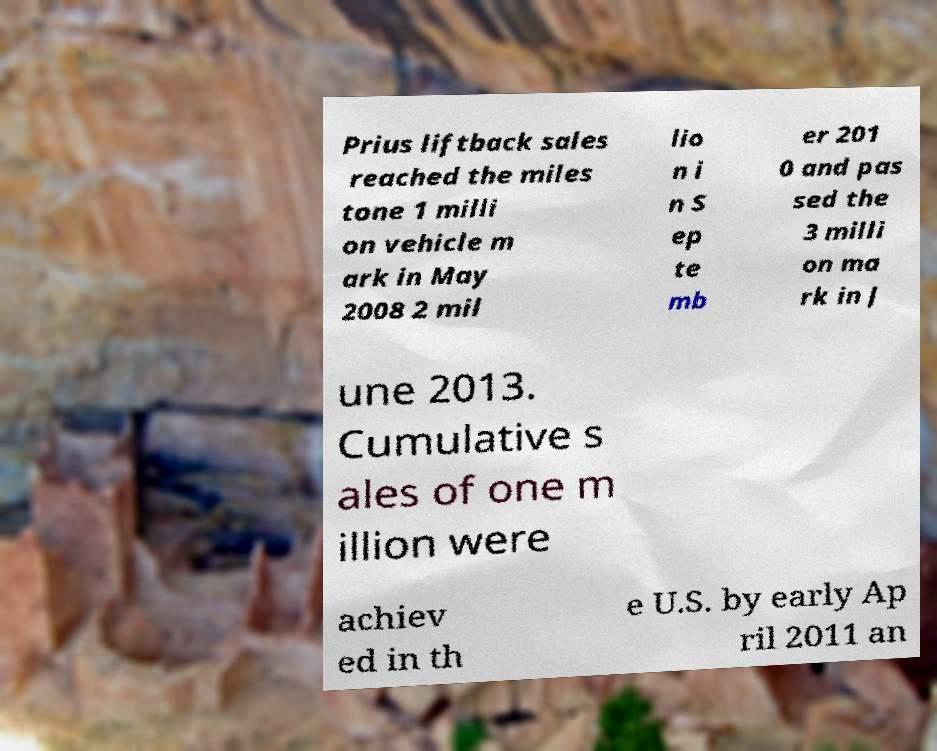Could you extract and type out the text from this image? Prius liftback sales reached the miles tone 1 milli on vehicle m ark in May 2008 2 mil lio n i n S ep te mb er 201 0 and pas sed the 3 milli on ma rk in J une 2013. Cumulative s ales of one m illion were achiev ed in th e U.S. by early Ap ril 2011 an 